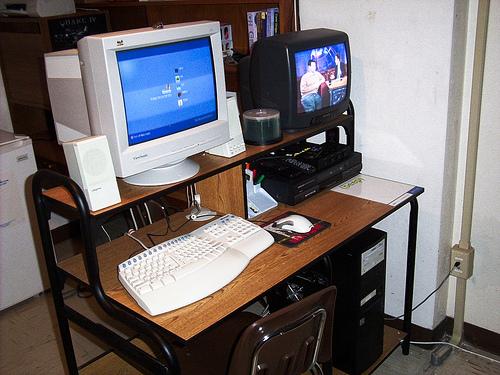What color is the computer?
Quick response, please. White. Is this a very modern system?
Concise answer only. No. Is the chair brown?
Short answer required. Yes. 